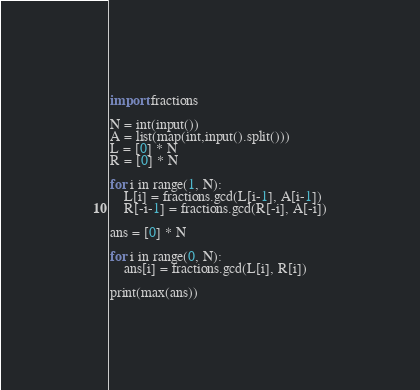<code> <loc_0><loc_0><loc_500><loc_500><_Python_>import fractions
 
N = int(input())
A = list(map(int,input().split()))
L = [0] * N
R = [0] * N

for i in range(1, N):
    L[i] = fractions.gcd(L[i-1], A[i-1])
    R[-i-1] = fractions.gcd(R[-i], A[-i])

ans = [0] * N

for i in range(0, N):
    ans[i] = fractions.gcd(L[i], R[i])

print(max(ans))</code> 